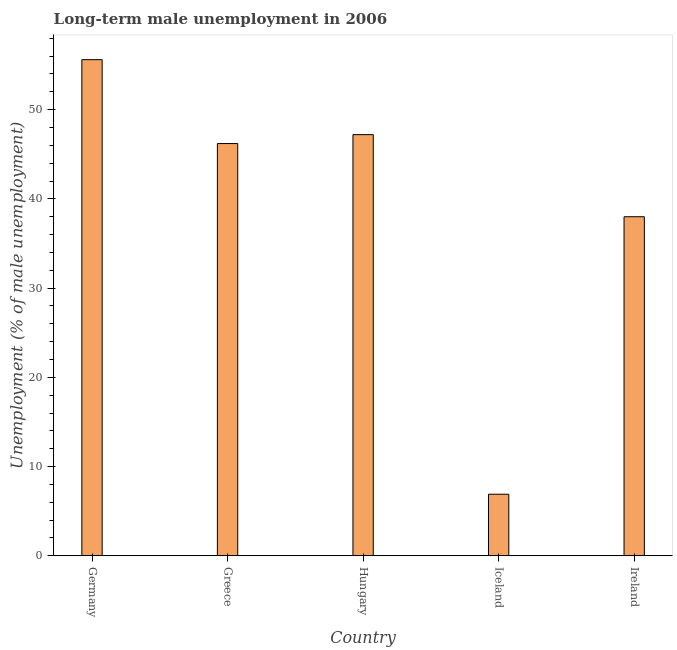Does the graph contain grids?
Provide a short and direct response. No. What is the title of the graph?
Provide a short and direct response. Long-term male unemployment in 2006. What is the label or title of the X-axis?
Your answer should be very brief. Country. What is the label or title of the Y-axis?
Offer a terse response. Unemployment (% of male unemployment). What is the long-term male unemployment in Germany?
Keep it short and to the point. 55.6. Across all countries, what is the maximum long-term male unemployment?
Your answer should be very brief. 55.6. Across all countries, what is the minimum long-term male unemployment?
Offer a terse response. 6.9. In which country was the long-term male unemployment maximum?
Provide a succinct answer. Germany. What is the sum of the long-term male unemployment?
Offer a terse response. 193.9. What is the difference between the long-term male unemployment in Germany and Hungary?
Your answer should be very brief. 8.4. What is the average long-term male unemployment per country?
Your answer should be compact. 38.78. What is the median long-term male unemployment?
Offer a very short reply. 46.2. What is the ratio of the long-term male unemployment in Germany to that in Iceland?
Ensure brevity in your answer.  8.06. Is the long-term male unemployment in Greece less than that in Ireland?
Offer a terse response. No. What is the difference between the highest and the second highest long-term male unemployment?
Your response must be concise. 8.4. Is the sum of the long-term male unemployment in Hungary and Iceland greater than the maximum long-term male unemployment across all countries?
Your answer should be compact. No. What is the difference between the highest and the lowest long-term male unemployment?
Keep it short and to the point. 48.7. In how many countries, is the long-term male unemployment greater than the average long-term male unemployment taken over all countries?
Offer a terse response. 3. How many bars are there?
Your answer should be compact. 5. What is the difference between two consecutive major ticks on the Y-axis?
Your answer should be compact. 10. Are the values on the major ticks of Y-axis written in scientific E-notation?
Your answer should be compact. No. What is the Unemployment (% of male unemployment) of Germany?
Give a very brief answer. 55.6. What is the Unemployment (% of male unemployment) in Greece?
Offer a terse response. 46.2. What is the Unemployment (% of male unemployment) of Hungary?
Provide a succinct answer. 47.2. What is the Unemployment (% of male unemployment) in Iceland?
Keep it short and to the point. 6.9. What is the difference between the Unemployment (% of male unemployment) in Germany and Hungary?
Ensure brevity in your answer.  8.4. What is the difference between the Unemployment (% of male unemployment) in Germany and Iceland?
Provide a short and direct response. 48.7. What is the difference between the Unemployment (% of male unemployment) in Greece and Hungary?
Offer a terse response. -1. What is the difference between the Unemployment (% of male unemployment) in Greece and Iceland?
Keep it short and to the point. 39.3. What is the difference between the Unemployment (% of male unemployment) in Hungary and Iceland?
Your answer should be compact. 40.3. What is the difference between the Unemployment (% of male unemployment) in Iceland and Ireland?
Make the answer very short. -31.1. What is the ratio of the Unemployment (% of male unemployment) in Germany to that in Greece?
Provide a short and direct response. 1.2. What is the ratio of the Unemployment (% of male unemployment) in Germany to that in Hungary?
Keep it short and to the point. 1.18. What is the ratio of the Unemployment (% of male unemployment) in Germany to that in Iceland?
Keep it short and to the point. 8.06. What is the ratio of the Unemployment (% of male unemployment) in Germany to that in Ireland?
Ensure brevity in your answer.  1.46. What is the ratio of the Unemployment (% of male unemployment) in Greece to that in Hungary?
Offer a very short reply. 0.98. What is the ratio of the Unemployment (% of male unemployment) in Greece to that in Iceland?
Your answer should be very brief. 6.7. What is the ratio of the Unemployment (% of male unemployment) in Greece to that in Ireland?
Your answer should be compact. 1.22. What is the ratio of the Unemployment (% of male unemployment) in Hungary to that in Iceland?
Your response must be concise. 6.84. What is the ratio of the Unemployment (% of male unemployment) in Hungary to that in Ireland?
Keep it short and to the point. 1.24. What is the ratio of the Unemployment (% of male unemployment) in Iceland to that in Ireland?
Give a very brief answer. 0.18. 